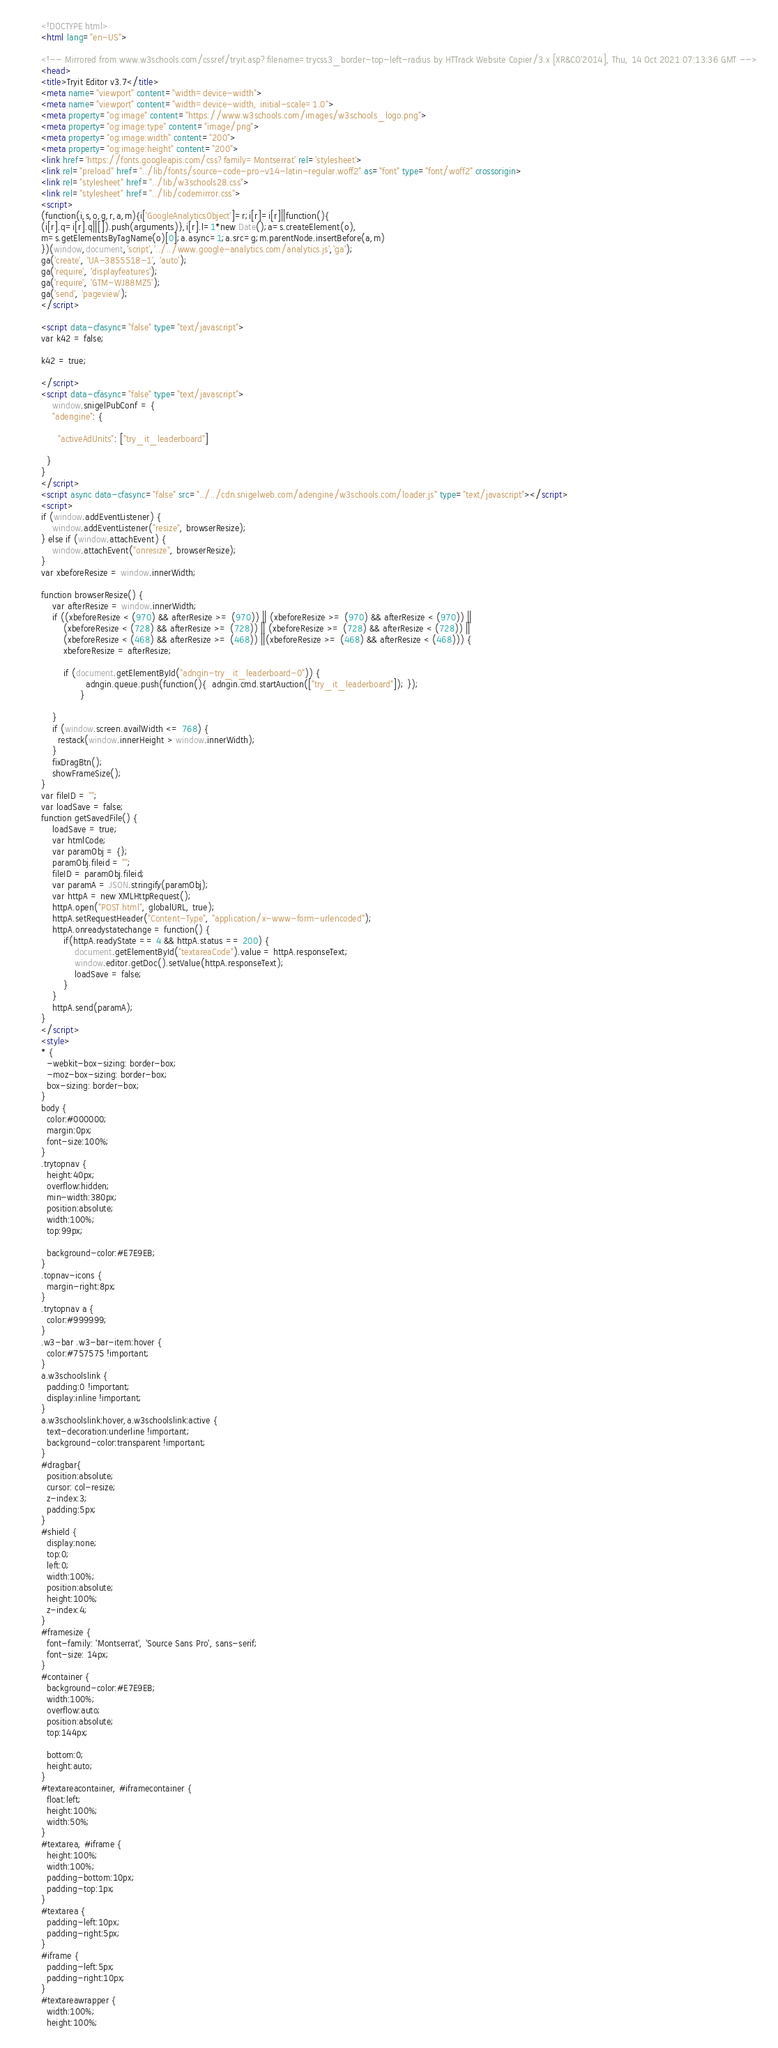<code> <loc_0><loc_0><loc_500><loc_500><_HTML_>
<!DOCTYPE html>
<html lang="en-US">

<!-- Mirrored from www.w3schools.com/cssref/tryit.asp?filename=trycss3_border-top-left-radius by HTTrack Website Copier/3.x [XR&CO'2014], Thu, 14 Oct 2021 07:13:36 GMT -->
<head>
<title>Tryit Editor v3.7</title>
<meta name="viewport" content="width=device-width">
<meta name="viewport" content="width=device-width, initial-scale=1.0">
<meta property="og:image" content="https://www.w3schools.com/images/w3schools_logo.png">
<meta property="og:image:type" content="image/png">
<meta property="og:image:width" content="200">
<meta property="og:image:height" content="200">
<link href='https://fonts.googleapis.com/css?family=Montserrat' rel='stylesheet'>
<link rel="preload" href="../lib/fonts/source-code-pro-v14-latin-regular.woff2" as="font" type="font/woff2" crossorigin>
<link rel="stylesheet" href="../lib/w3schools28.css">
<link rel="stylesheet" href="../lib/codemirror.css">
<script>
(function(i,s,o,g,r,a,m){i['GoogleAnalyticsObject']=r;i[r]=i[r]||function(){
(i[r].q=i[r].q||[]).push(arguments)},i[r].l=1*new Date();a=s.createElement(o),
m=s.getElementsByTagName(o)[0];a.async=1;a.src=g;m.parentNode.insertBefore(a,m)
})(window,document,'script','../../www.google-analytics.com/analytics.js','ga');
ga('create', 'UA-3855518-1', 'auto');
ga('require', 'displayfeatures');
ga('require', 'GTM-WJ88MZ5');
ga('send', 'pageview');
</script>

<script data-cfasync="false" type="text/javascript">
var k42 = false;

k42 = true;

</script>
<script data-cfasync="false" type="text/javascript">
    window.snigelPubConf = {
    "adengine": {

      "activeAdUnits": ["try_it_leaderboard"]

  }
}
</script>
<script async data-cfasync="false" src="../../cdn.snigelweb.com/adengine/w3schools.com/loader.js" type="text/javascript"></script>
<script>
if (window.addEventListener) {              
    window.addEventListener("resize", browserResize);
} else if (window.attachEvent) {                 
    window.attachEvent("onresize", browserResize);
}
var xbeforeResize = window.innerWidth;

function browserResize() {
    var afterResize = window.innerWidth;
    if ((xbeforeResize < (970) && afterResize >= (970)) || (xbeforeResize >= (970) && afterResize < (970)) ||
        (xbeforeResize < (728) && afterResize >= (728)) || (xbeforeResize >= (728) && afterResize < (728)) ||
        (xbeforeResize < (468) && afterResize >= (468)) ||(xbeforeResize >= (468) && afterResize < (468))) {
        xbeforeResize = afterResize;
        
        if (document.getElementById("adngin-try_it_leaderboard-0")) {
                adngin.queue.push(function(){  adngin.cmd.startAuction(["try_it_leaderboard"]); });
              }
         
    }
    if (window.screen.availWidth <= 768) {
      restack(window.innerHeight > window.innerWidth);
    }
    fixDragBtn();
    showFrameSize();    
}
var fileID = "";
var loadSave = false;
function getSavedFile() {
    loadSave = true;
    var htmlCode;
    var paramObj = {};
    paramObj.fileid = "";
    fileID = paramObj.fileid;
    var paramA = JSON.stringify(paramObj);
    var httpA = new XMLHttpRequest();
    httpA.open("POST.html", globalURL, true);
    httpA.setRequestHeader("Content-Type", "application/x-www-form-urlencoded");
    httpA.onreadystatechange = function() {
        if(httpA.readyState == 4 && httpA.status == 200) {
            document.getElementById("textareaCode").value = httpA.responseText;
            window.editor.getDoc().setValue(httpA.responseText);
            loadSave = false;
        }
    }
    httpA.send(paramA);   
}
</script>
<style>
* {
  -webkit-box-sizing: border-box;
  -moz-box-sizing: border-box;
  box-sizing: border-box;
}
body {
  color:#000000;
  margin:0px;
  font-size:100%;
}
.trytopnav {
  height:40px;
  overflow:hidden;
  min-width:380px;
  position:absolute;
  width:100%;
  top:99px;

  background-color:#E7E9EB;
}
.topnav-icons {
  margin-right:8px;
}
.trytopnav a {
  color:#999999;
}
.w3-bar .w3-bar-item:hover {
  color:#757575 !important;
}
a.w3schoolslink {
  padding:0 !important;
  display:inline !important;
}
a.w3schoolslink:hover,a.w3schoolslink:active {
  text-decoration:underline !important;
  background-color:transparent !important;
}
#dragbar{
  position:absolute;
  cursor: col-resize;
  z-index:3;
  padding:5px;
}
#shield {
  display:none;
  top:0;
  left:0;
  width:100%;
  position:absolute;
  height:100%;
  z-index:4;
}
#framesize {
  font-family: 'Montserrat', 'Source Sans Pro', sans-serif;
  font-size: 14px;
}
#container {
  background-color:#E7E9EB;
  width:100%;
  overflow:auto;
  position:absolute;
  top:144px;

  bottom:0;
  height:auto;
}
#textareacontainer, #iframecontainer {
  float:left;
  height:100%;
  width:50%;
}
#textarea, #iframe {
  height:100%;
  width:100%;
  padding-bottom:10px;
  padding-top:1px;
}
#textarea {
  padding-left:10px;
  padding-right:5px;  
}
#iframe {
  padding-left:5px;
  padding-right:10px;  
}
#textareawrapper {
  width:100%;
  height:100%;</code> 